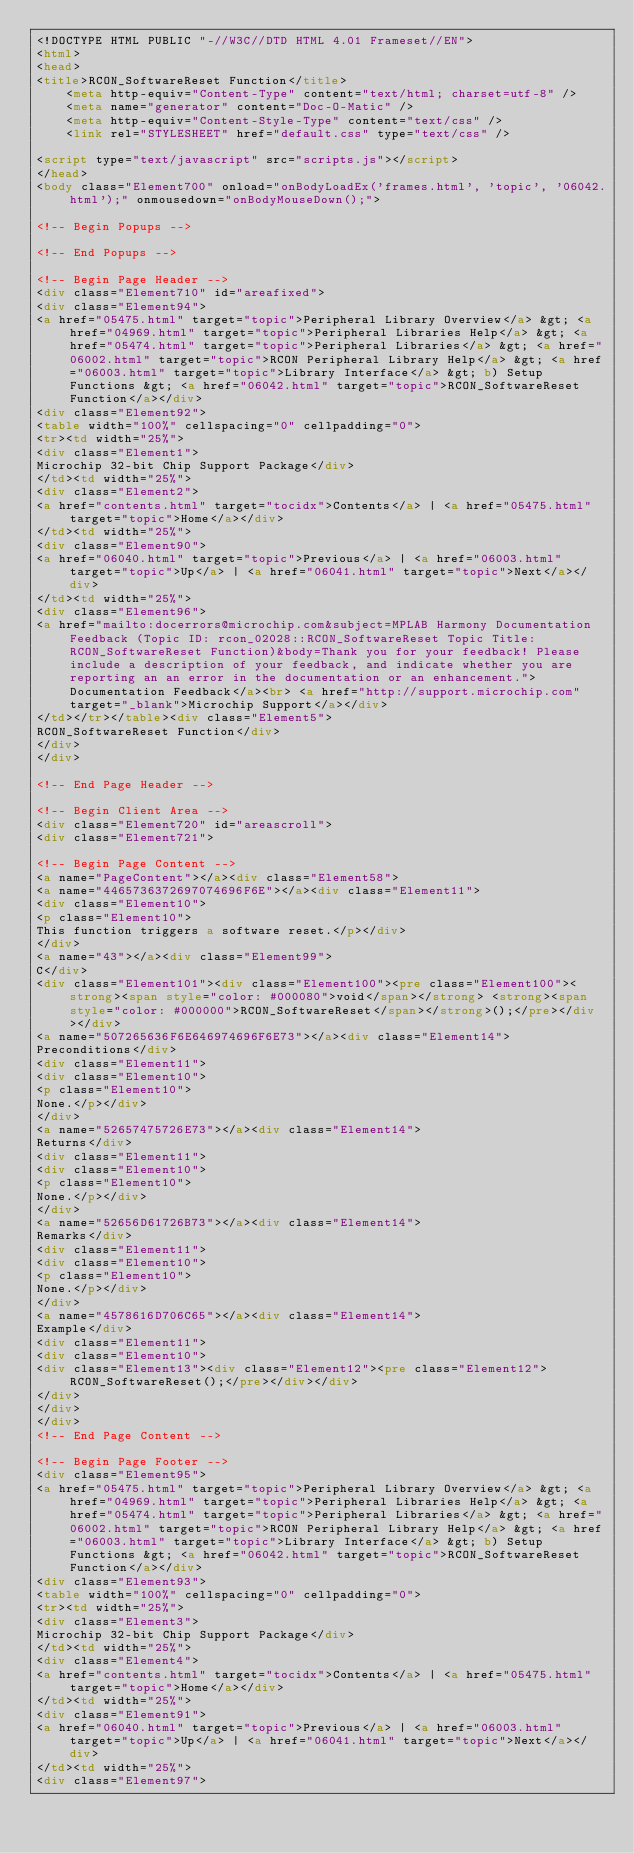<code> <loc_0><loc_0><loc_500><loc_500><_HTML_><!DOCTYPE HTML PUBLIC "-//W3C//DTD HTML 4.01 Frameset//EN">
<html>
<head>
<title>RCON_SoftwareReset Function</title>
    <meta http-equiv="Content-Type" content="text/html; charset=utf-8" />
    <meta name="generator" content="Doc-O-Matic" />
    <meta http-equiv="Content-Style-Type" content="text/css" />
    <link rel="STYLESHEET" href="default.css" type="text/css" />

<script type="text/javascript" src="scripts.js"></script>
</head>
<body class="Element700" onload="onBodyLoadEx('frames.html', 'topic', '06042.html');" onmousedown="onBodyMouseDown();">

<!-- Begin Popups -->

<!-- End Popups -->

<!-- Begin Page Header -->
<div class="Element710" id="areafixed">
<div class="Element94">
<a href="05475.html" target="topic">Peripheral Library Overview</a> &gt; <a href="04969.html" target="topic">Peripheral Libraries Help</a> &gt; <a href="05474.html" target="topic">Peripheral Libraries</a> &gt; <a href="06002.html" target="topic">RCON Peripheral Library Help</a> &gt; <a href="06003.html" target="topic">Library Interface</a> &gt; b) Setup Functions &gt; <a href="06042.html" target="topic">RCON_SoftwareReset Function</a></div>
<div class="Element92">
<table width="100%" cellspacing="0" cellpadding="0">
<tr><td width="25%">
<div class="Element1">
Microchip 32-bit Chip Support Package</div>
</td><td width="25%">
<div class="Element2">
<a href="contents.html" target="tocidx">Contents</a> | <a href="05475.html" target="topic">Home</a></div>
</td><td width="25%">
<div class="Element90">
<a href="06040.html" target="topic">Previous</a> | <a href="06003.html" target="topic">Up</a> | <a href="06041.html" target="topic">Next</a></div>
</td><td width="25%">
<div class="Element96">
<a href="mailto:docerrors@microchip.com&subject=MPLAB Harmony Documentation Feedback (Topic ID: rcon_02028::RCON_SoftwareReset Topic Title: RCON_SoftwareReset Function)&body=Thank you for your feedback! Please include a description of your feedback, and indicate whether you are reporting an an error in the documentation or an enhancement.">Documentation Feedback</a><br> <a href="http://support.microchip.com" target="_blank">Microchip Support</a></div>
</td></tr></table><div class="Element5">
RCON_SoftwareReset Function</div>
</div>
</div>

<!-- End Page Header -->

<!-- Begin Client Area -->
<div class="Element720" id="areascroll">
<div class="Element721">

<!-- Begin Page Content -->
<a name="PageContent"></a><div class="Element58">
<a name="4465736372697074696F6E"></a><div class="Element11">
<div class="Element10">
<p class="Element10">
This function triggers a software reset.</p></div>
</div>
<a name="43"></a><div class="Element99">
C</div>
<div class="Element101"><div class="Element100"><pre class="Element100"><strong><span style="color: #000080">void</span></strong> <strong><span style="color: #000000">RCON_SoftwareReset</span></strong>();</pre></div></div>
<a name="507265636F6E646974696F6E73"></a><div class="Element14">
Preconditions</div>
<div class="Element11">
<div class="Element10">
<p class="Element10">
None.</p></div>
</div>
<a name="52657475726E73"></a><div class="Element14">
Returns</div>
<div class="Element11">
<div class="Element10">
<p class="Element10">
None.</p></div>
</div>
<a name="52656D61726B73"></a><div class="Element14">
Remarks</div>
<div class="Element11">
<div class="Element10">
<p class="Element10">
None.</p></div>
</div>
<a name="4578616D706C65"></a><div class="Element14">
Example</div>
<div class="Element11">
<div class="Element10">
<div class="Element13"><div class="Element12"><pre class="Element12">RCON_SoftwareReset();</pre></div></div>
</div>
</div>
</div>
<!-- End Page Content -->

<!-- Begin Page Footer -->
<div class="Element95">
<a href="05475.html" target="topic">Peripheral Library Overview</a> &gt; <a href="04969.html" target="topic">Peripheral Libraries Help</a> &gt; <a href="05474.html" target="topic">Peripheral Libraries</a> &gt; <a href="06002.html" target="topic">RCON Peripheral Library Help</a> &gt; <a href="06003.html" target="topic">Library Interface</a> &gt; b) Setup Functions &gt; <a href="06042.html" target="topic">RCON_SoftwareReset Function</a></div>
<div class="Element93">
<table width="100%" cellspacing="0" cellpadding="0">
<tr><td width="25%">
<div class="Element3">
Microchip 32-bit Chip Support Package</div>
</td><td width="25%">
<div class="Element4">
<a href="contents.html" target="tocidx">Contents</a> | <a href="05475.html" target="topic">Home</a></div>
</td><td width="25%">
<div class="Element91">
<a href="06040.html" target="topic">Previous</a> | <a href="06003.html" target="topic">Up</a> | <a href="06041.html" target="topic">Next</a></div>
</td><td width="25%">
<div class="Element97"></code> 